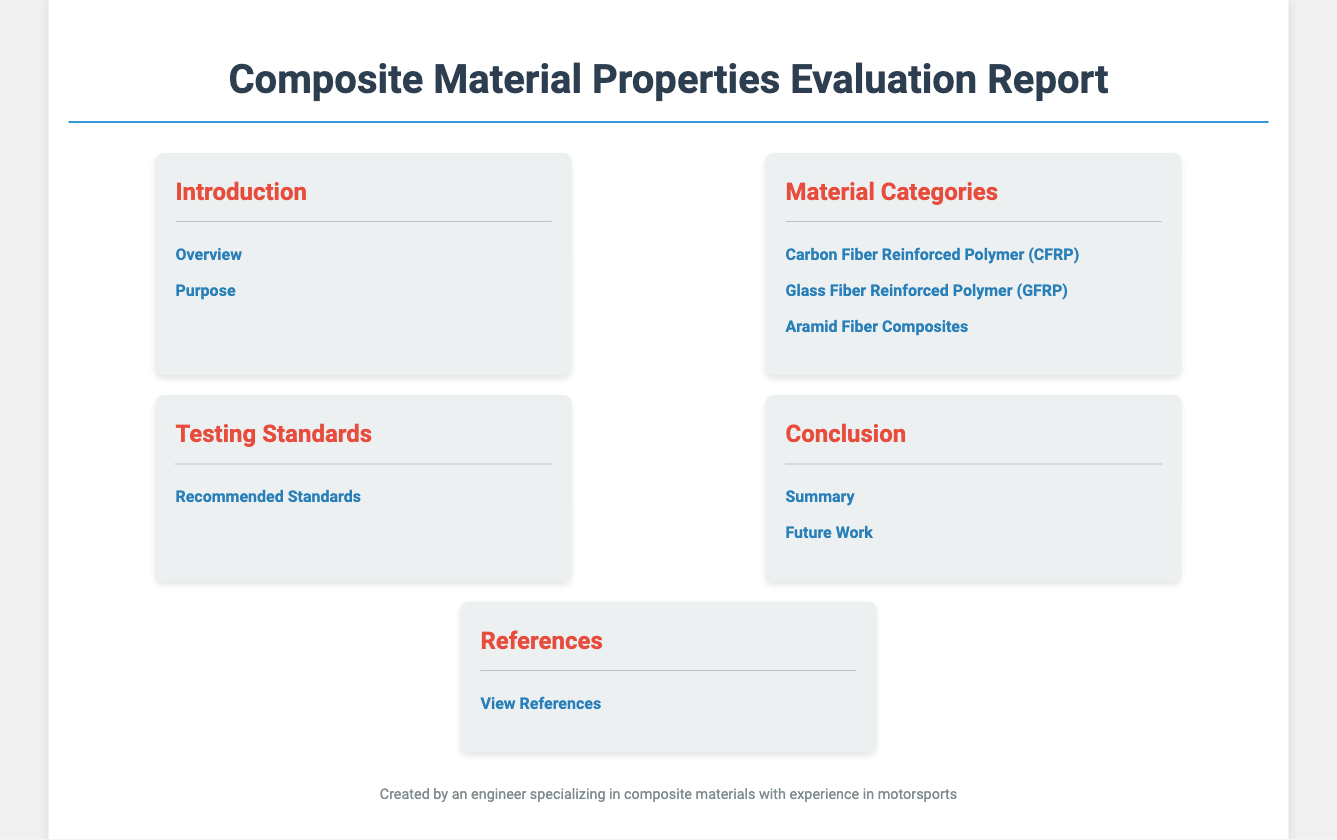What is the title of the document? The title is prominently displayed at the top of the document.
Answer: Composite Material Properties Evaluation Report How many material categories are listed? The document menu lists three specific material categories.
Answer: Three What is the first material category mentioned? The first item under "Material Categories" in the menu indicates the type of material.
Answer: Carbon Fiber Reinforced Polymer (CFRP) What section contains the recommended testing standards? The "Testing Standards" menu item provides insight into the relevant standards for evaluating composite materials.
Answer: Recommended Standards What does the "Conclusion" section summarize? The "Conclusion" section menu outlines two specific topics that the conclusion will address.
Answer: Summary What is the last menu item listed in the document? The last item in the menu provides information on further reading or citations used in the report.
Answer: References 